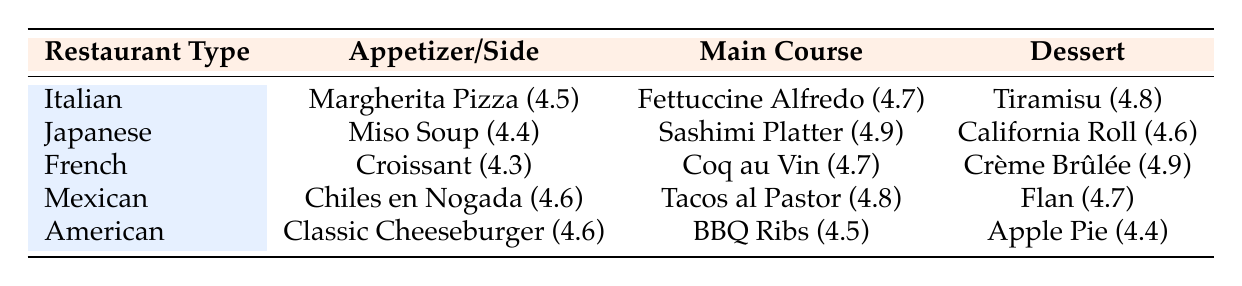What is the average rating of desserts in the Italian restaurant? The dessert in the Italian category is Tiramisu with an average rating of 4.8. Since there is only one dessert listed, the average rating is equal to the rating of that dessert.
Answer: 4.8 Which restaurant has the highest-rated main course? The main courses and their ratings are: Fettuccine Alfredo (4.7) at Italian, Sashimi Platter (4.9) at Japanese, Coq au Vin (4.7) at French, Tacos al Pastor (4.8) at Mexican, and BBQ Ribs (4.5) at American. The Sashimi Platter at Japanese has the highest rating at 4.9.
Answer: Japanese Is the average rating of the appetizers higher than 4.5? The appetizers and their ratings are: Margherita Pizza (4.5) at Italian, Miso Soup (4.4) at Japanese, Croissant (4.3) at French, Chiles en Nogada (4.6) at Mexican, and Classic Cheeseburger (4.6) at American. To find the average, we add the ratings (4.5 + 4.4 + 4.3 + 4.6 + 4.6) = 22.4 and divide by 5 to get 22.4 / 5 = 4.48, which is higher than 4.5.
Answer: Yes What is the difference between the highest and lowest-rated dessert in the table? The highest-rated dessert is Crème Brûlée at 4.9 and the lowest is Apple Pie at 4.4. To find the difference, we subtract the lowest from the highest: 4.9 - 4.4 = 0.5.
Answer: 0.5 Are there any American restaurant menu items that have ratings above 4.6? The American restaurant has three items: Classic Cheeseburger (4.6), BBQ Ribs (4.5), and Apple Pie (4.4). Here, only the Classic Cheeseburger has a rating of exactly 4.6, which fits the criteria for being above or equal to 4.6, thus the answer is yes.
Answer: Yes What is the average rating of all main courses in the table? The main courses and their ratings are: Fettuccine Alfredo (4.7), Sashimi Platter (4.9), Coq au Vin (4.7), Tacos al Pastor (4.8), and BBQ Ribs (4.5). The sum of these ratings is (4.7 + 4.9 + 4.7 + 4.8 + 4.5) = 24.6. We divide this sum by the number of main courses (5), resulting in an average rating of 24.6 / 5 = 4.92.
Answer: 4.92 